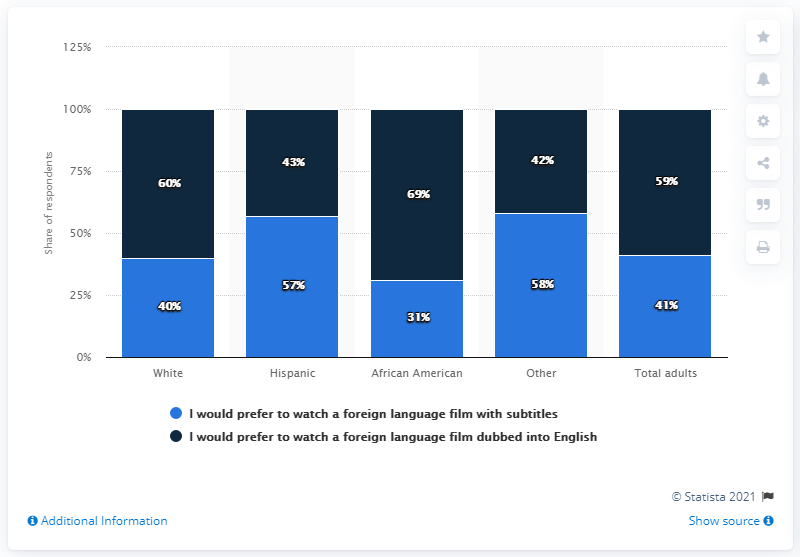Highlight a few significant elements in this photo. According to a survey, 59% of U.S. adults stated that they prefer to watch foreign language films with English dubbing. 